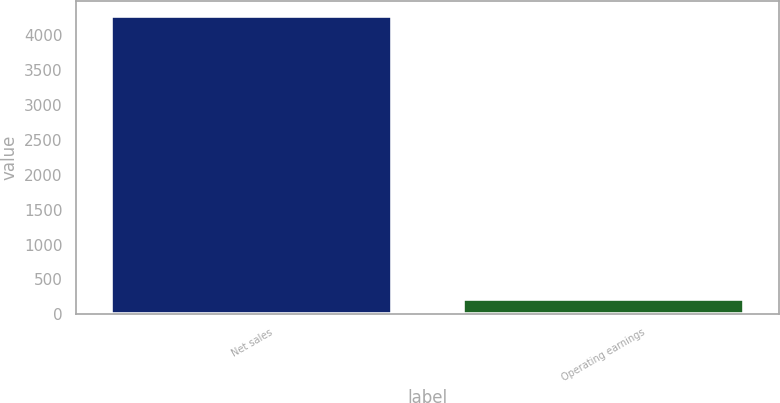<chart> <loc_0><loc_0><loc_500><loc_500><bar_chart><fcel>Net sales<fcel>Operating earnings<nl><fcel>4271<fcel>216<nl></chart> 